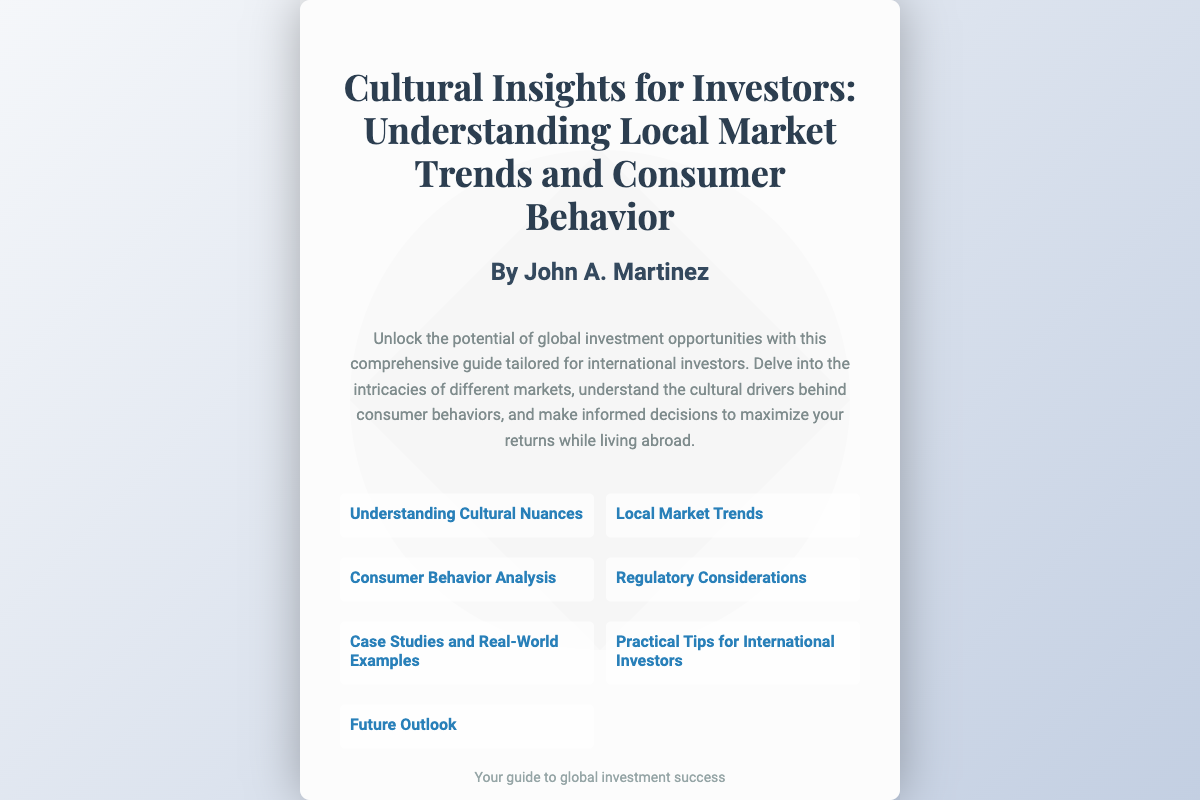What is the title of the book? The title is prominently displayed at the top of the document, stating the main focus of the book.
Answer: Cultural Insights for Investors: Understanding Local Market Trends and Consumer Behavior Who is the author of the book? The name of the author is given below the title in a larger font size for easy identification.
Answer: John A. Martinez What is the main purpose of the book? The description section outlines the goal of the book, which is to provide guidance for a specific audience.
Answer: Unlock the potential of global investment opportunities What are the types of insights covered in the book? The sections listed reveal the various topics the book addresses, showcasing its comprehensive nature.
Answer: Understanding Cultural Nuances, Local Market Trends, Consumer Behavior Analysis, Regulatory Considerations, Case Studies and Real-World Examples, Practical Tips for International Investors, Future Outlook How many sections are listed in the document? By counting the sections displayed, we can determine the total number of topics covered.
Answer: Seven What is a key focus area for investors as per the book? By analyzing the section headings, we can identify a specific area of interest highlighted for investors.
Answer: Local Market Trends What is the significance of understanding cultural nuances? This question synthesizes knowledge from multiple sections, particularly regarding how it relates to investment decisions.
Answer: To make informed decisions 